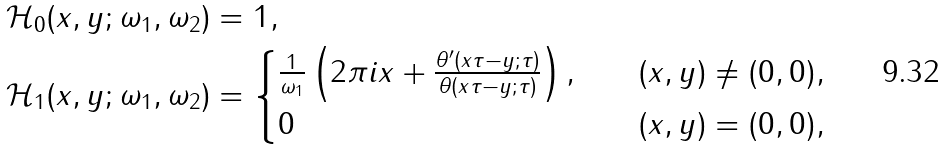<formula> <loc_0><loc_0><loc_500><loc_500>& \mathcal { H } _ { 0 } ( x , y ; \omega _ { 1 } , \omega _ { 2 } ) = 1 , \\ & \mathcal { H } _ { 1 } ( x , y ; \omega _ { 1 } , \omega _ { 2 } ) = \begin{cases} \frac { 1 } { \omega _ { 1 } } \left ( 2 \pi i x + \frac { \theta ^ { \prime } ( x \tau - y ; \tau ) } { \theta ( x \tau - y ; \tau ) } \right ) , \quad & ( x , y ) \neq ( 0 , 0 ) , \\ 0 \quad & ( x , y ) = ( 0 , 0 ) , \end{cases}</formula> 